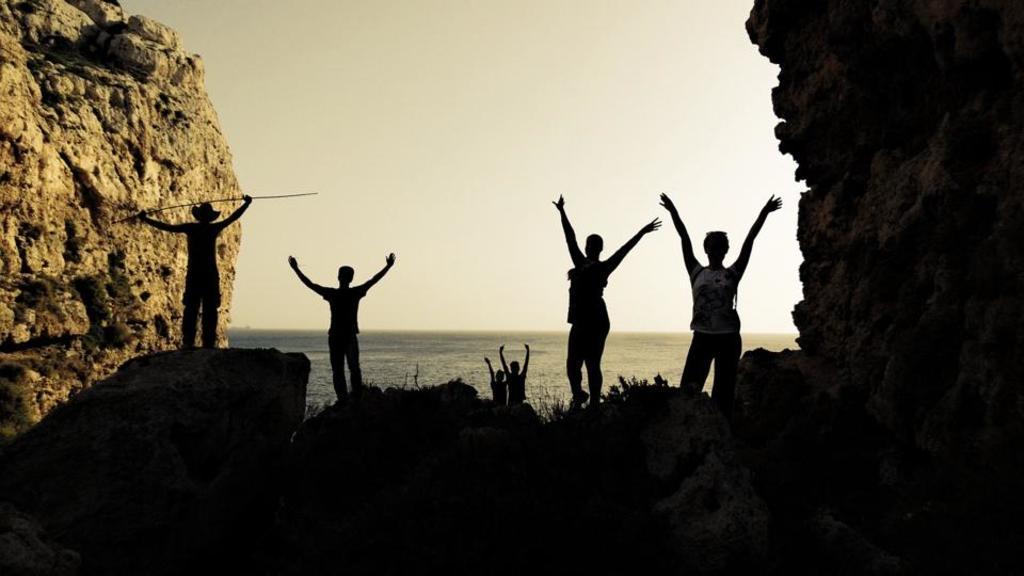In one or two sentences, can you explain what this image depicts? In this image we can see the people standing on the rocks and the other person holding stick. We can see the rocks on both sides. In the background, we can see the water and sky. 